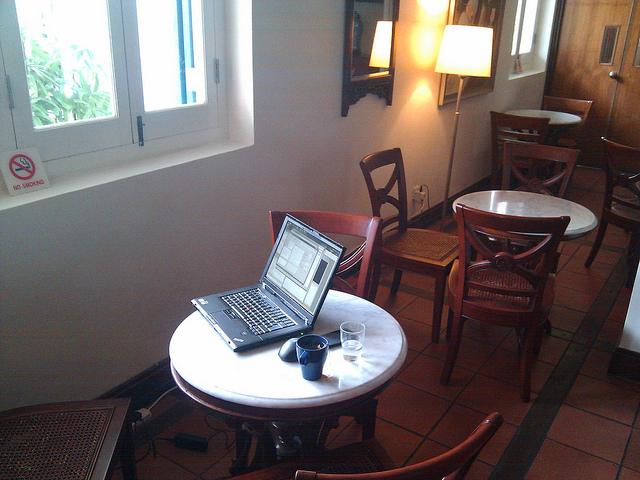What does the sign on the left say?
Write a very short answer. No smoking. What kind of computer is that?
Concise answer only. Laptop. Is the light on?
Quick response, please. Yes. 